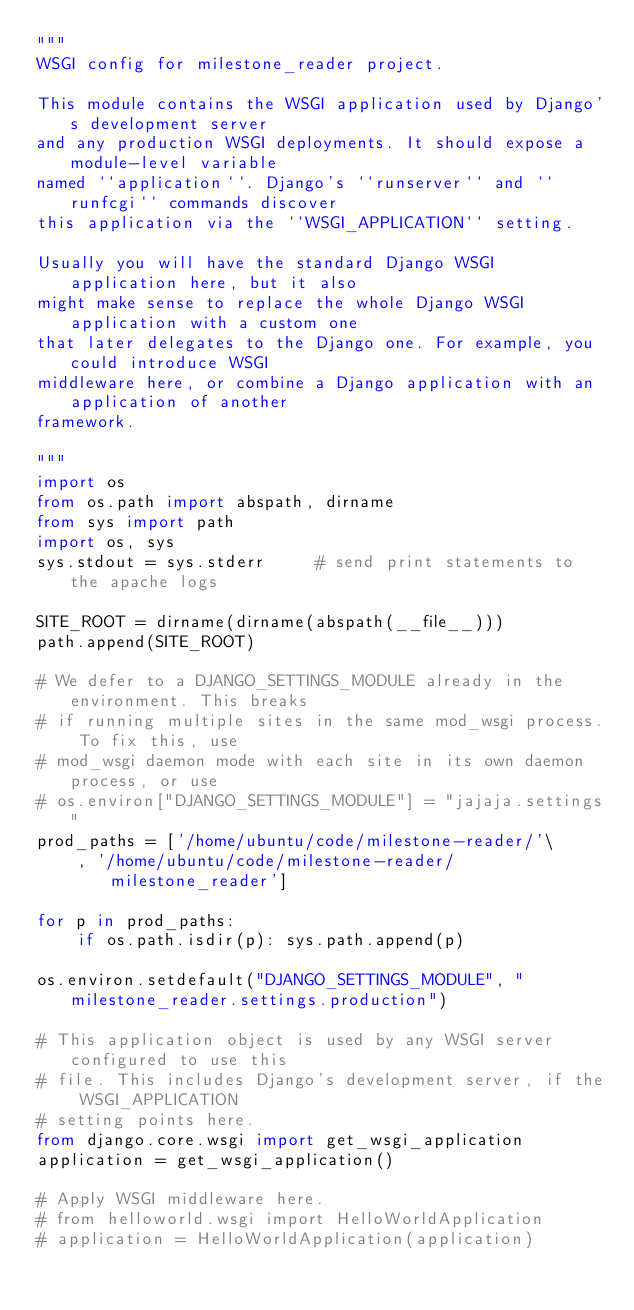<code> <loc_0><loc_0><loc_500><loc_500><_Python_>"""
WSGI config for milestone_reader project.

This module contains the WSGI application used by Django's development server
and any production WSGI deployments. It should expose a module-level variable
named ``application``. Django's ``runserver`` and ``runfcgi`` commands discover
this application via the ``WSGI_APPLICATION`` setting.

Usually you will have the standard Django WSGI application here, but it also
might make sense to replace the whole Django WSGI application with a custom one
that later delegates to the Django one. For example, you could introduce WSGI
middleware here, or combine a Django application with an application of another
framework.

"""
import os
from os.path import abspath, dirname
from sys import path
import os, sys
sys.stdout = sys.stderr     # send print statements to the apache logs

SITE_ROOT = dirname(dirname(abspath(__file__)))
path.append(SITE_ROOT)

# We defer to a DJANGO_SETTINGS_MODULE already in the environment. This breaks
# if running multiple sites in the same mod_wsgi process. To fix this, use
# mod_wsgi daemon mode with each site in its own daemon process, or use
# os.environ["DJANGO_SETTINGS_MODULE"] = "jajaja.settings"
prod_paths = ['/home/ubuntu/code/milestone-reader/'\
    , '/home/ubuntu/code/milestone-reader/milestone_reader']

for p in prod_paths:
    if os.path.isdir(p): sys.path.append(p)

os.environ.setdefault("DJANGO_SETTINGS_MODULE", "milestone_reader.settings.production")

# This application object is used by any WSGI server configured to use this
# file. This includes Django's development server, if the WSGI_APPLICATION
# setting points here.
from django.core.wsgi import get_wsgi_application
application = get_wsgi_application()

# Apply WSGI middleware here.
# from helloworld.wsgi import HelloWorldApplication
# application = HelloWorldApplication(application)
</code> 